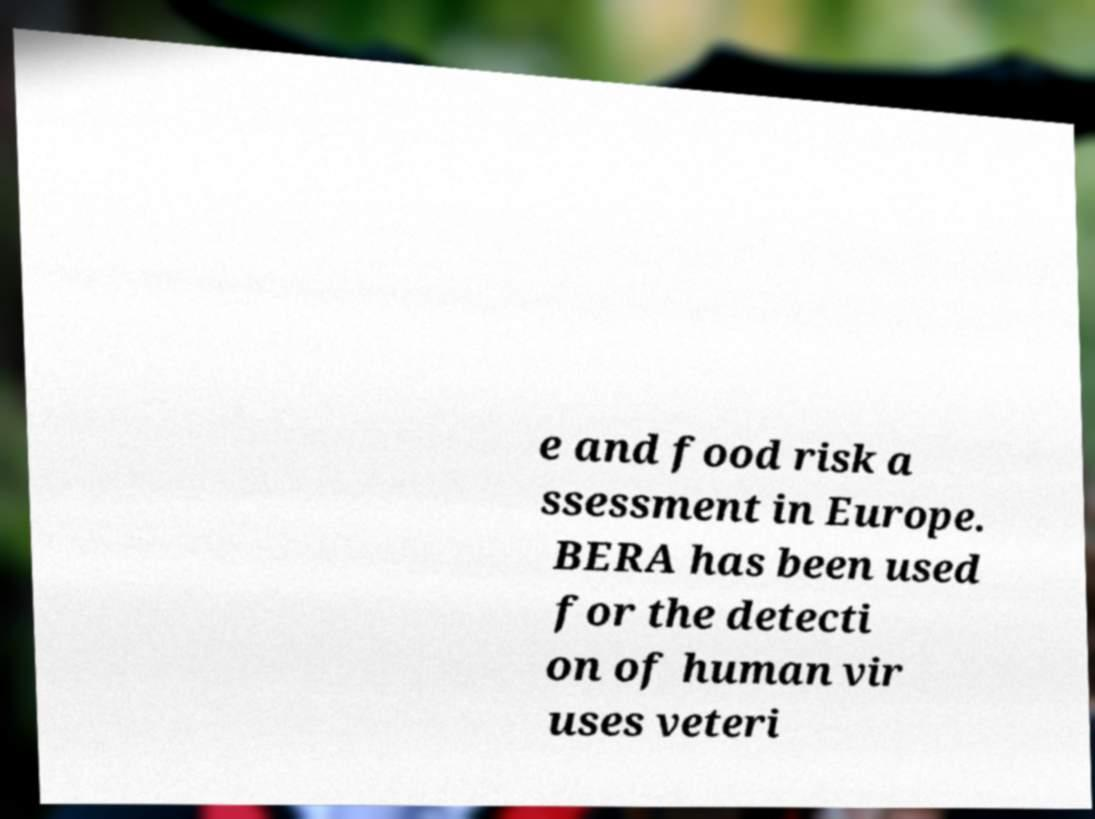Could you extract and type out the text from this image? e and food risk a ssessment in Europe. BERA has been used for the detecti on of human vir uses veteri 